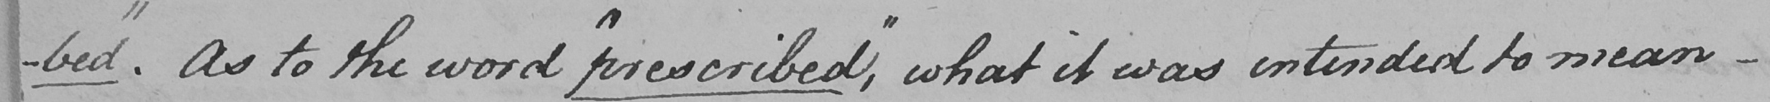Can you read and transcribe this handwriting? -bed "  . As to the word  " prescribed , "  what it was intended to mean - 